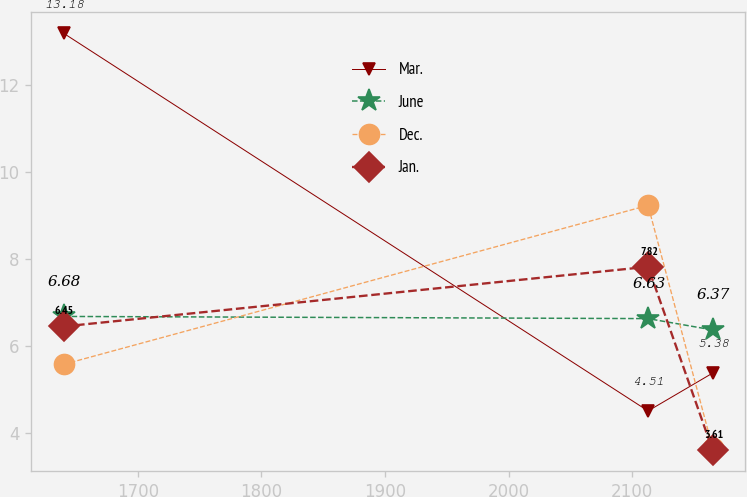Convert chart. <chart><loc_0><loc_0><loc_500><loc_500><line_chart><ecel><fcel>Mar.<fcel>June<fcel>Dec.<fcel>Jan.<nl><fcel>1639.97<fcel>13.18<fcel>6.68<fcel>5.58<fcel>6.45<nl><fcel>2112.82<fcel>4.51<fcel>6.63<fcel>9.23<fcel>7.82<nl><fcel>2165.11<fcel>5.38<fcel>6.37<fcel>3.66<fcel>3.61<nl></chart> 